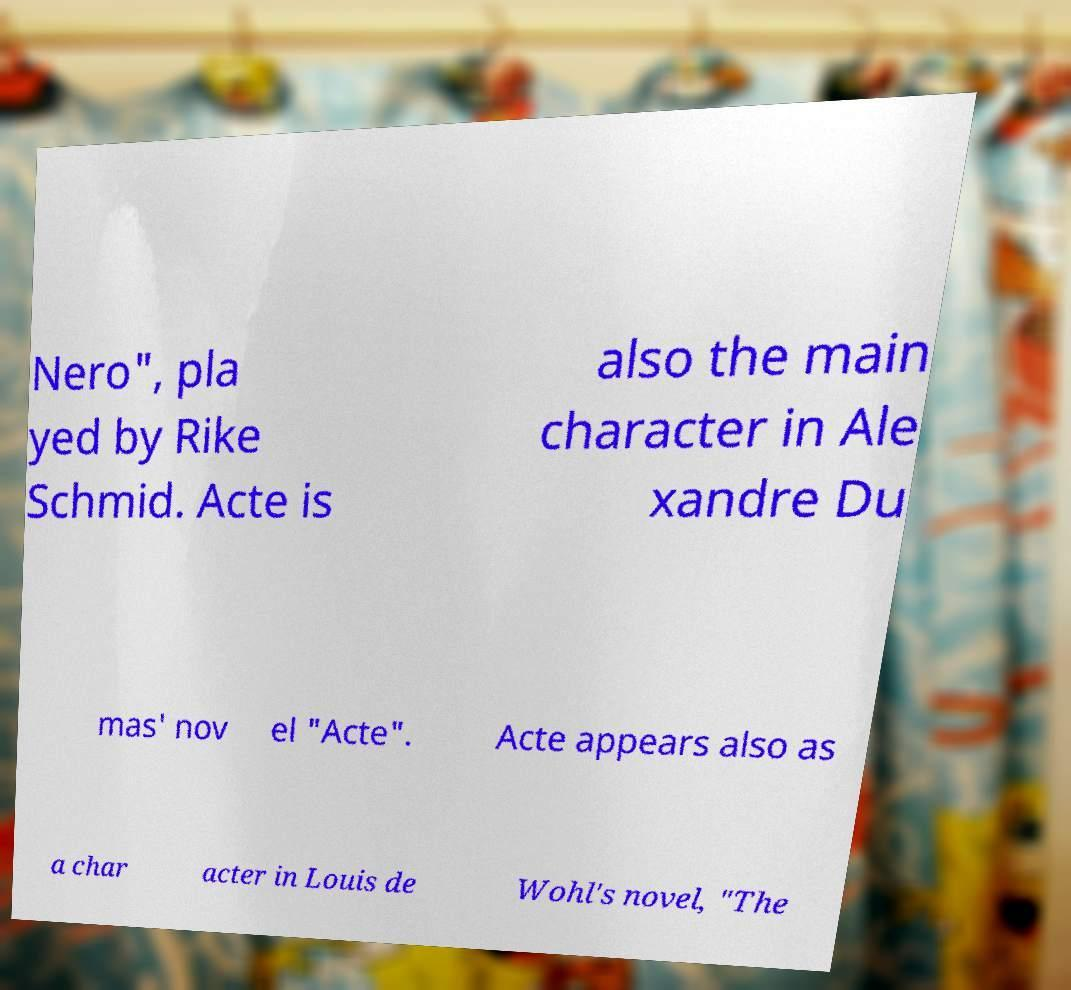What messages or text are displayed in this image? I need them in a readable, typed format. Nero", pla yed by Rike Schmid. Acte is also the main character in Ale xandre Du mas' nov el "Acte". Acte appears also as a char acter in Louis de Wohl's novel, "The 